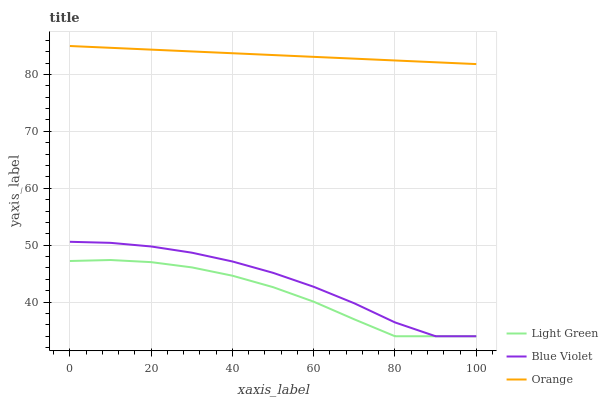Does Blue Violet have the minimum area under the curve?
Answer yes or no. No. Does Blue Violet have the maximum area under the curve?
Answer yes or no. No. Is Light Green the smoothest?
Answer yes or no. No. Is Light Green the roughest?
Answer yes or no. No. Does Blue Violet have the highest value?
Answer yes or no. No. Is Blue Violet less than Orange?
Answer yes or no. Yes. Is Orange greater than Light Green?
Answer yes or no. Yes. Does Blue Violet intersect Orange?
Answer yes or no. No. 